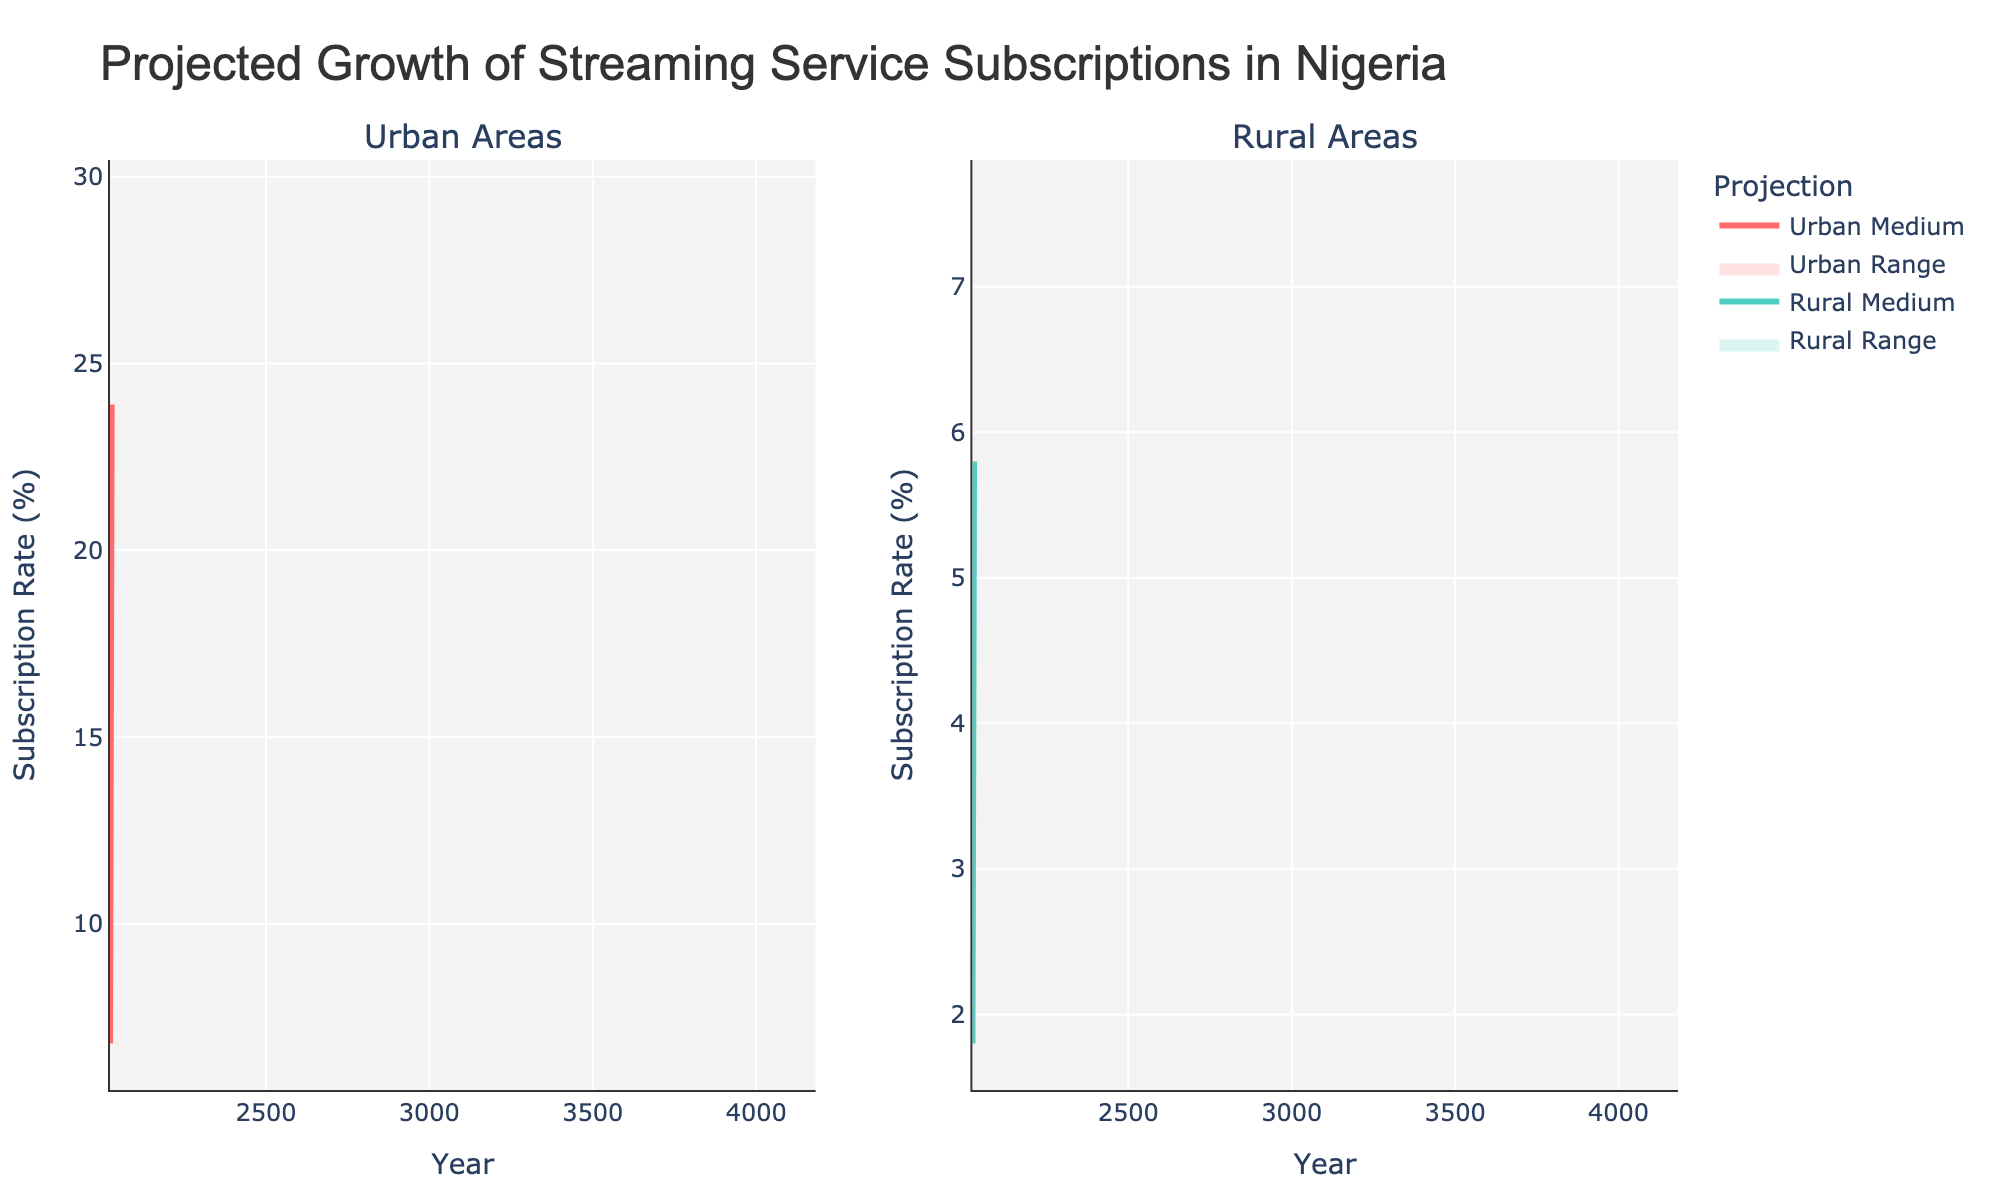what is the title of the figure? The title of the figure is prominently displayed at the top of the plot. It provides a summary of what the figure represents.
Answer: Projected Growth of Streaming Service Subscriptions in Nigeria How many years are shown on the x-axis? The x-axis represents the timeline for the data. By counting the distinct data points along the x-axis, we can determine the number of years.
Answer: 6 What's the subscription rate range for urban areas in 2025? To determine the subscription rate range for urban areas in 2025, we look at the values for Urban_Low and Urban_High for the year 2025.
Answer: 9.4% to 15.1% In which year is the medium urban subscription rate expected to be 19.5%? We need to identify the year where the Urban_Medium subscription rate is 19.5%. This is found by looking at the urban medium data points.
Answer: 2027 Compare the medium subscription rates of urban and rural areas in 2026. We compare the medium subscription rates for both urban and rural areas for the year 2026. From the plot, we find and compare these values.
Answer: Urban: 15.6%, Rural: 3.9% What is the difference between the high subscription rates in urban and rural areas in 2024? To find the difference, we subtract the rural high subscription rate from the urban high subscription rate for the year 2024. So, Urban_High - Rural_High = 11.6 - 3.3 = 8.3.
Answer: 8.3% What trend can you observe in the suburban areas from 2023 to 2028? By looking at the medium subscription rates over the years, we can observe a consistent trend of increase in the subscription rates in suburban areas from 2023 to 2028.
Answer: Increasing trend What’s the projected medium subscription rate in rural areas for the final year? The final year in the data is 2028, and we look at the Rural_Medium subscription rate for that year.
Answer: 5.8% How does the range of subscription rates in urban areas change from 2023 to 2028? By looking at both the low and high subscription rates for urban areas across the years from 2023 to 2028, we can see how the range expands.
Answer: The range increases What is the growth in urban medium subscription rates from 2023 to 2025? We calculate the difference between the urban medium subscription rates in 2025 and 2023, which is 12.2% - 6.8% = 5.4%.
Answer: 5.4% 